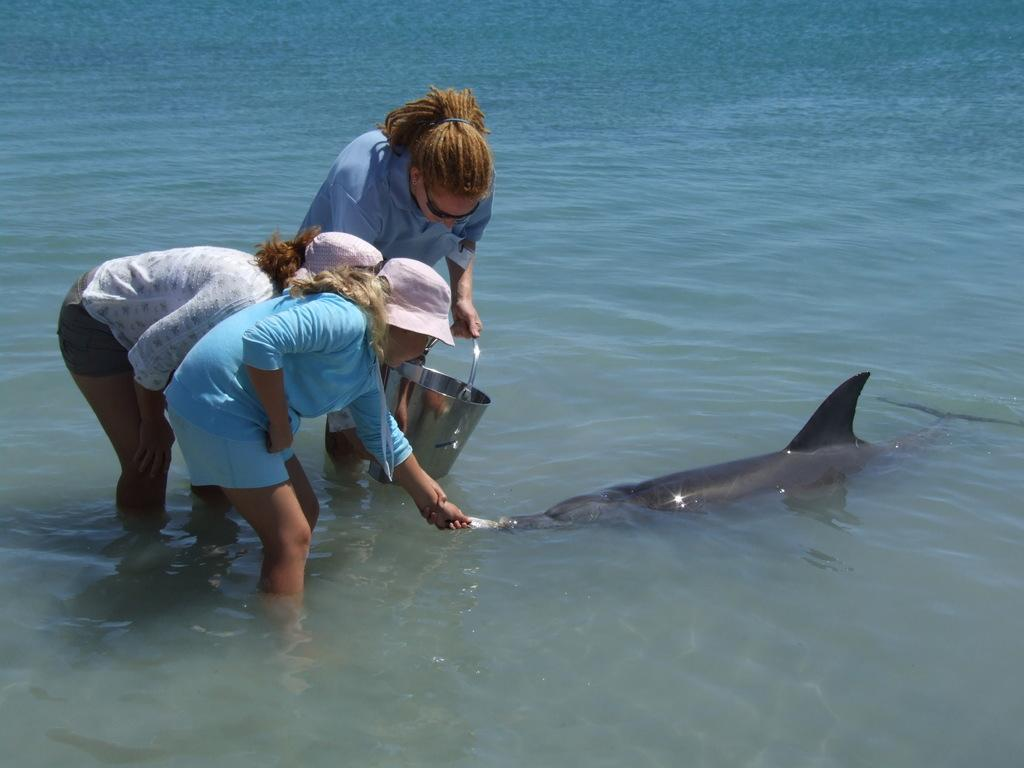How many people are in the image? There are three women in the image. What activity are the women engaged in? The women are fishing in the sea. Can you describe any specific items or tools being used by the women? One of the women is holding a cane. What type of protest is taking place in the image? There is no protest present in the image; it features three women fishing in the sea. Can you tell me what kind of notebook the tiger is using in the image? There is no tiger or notebook present in the image. 